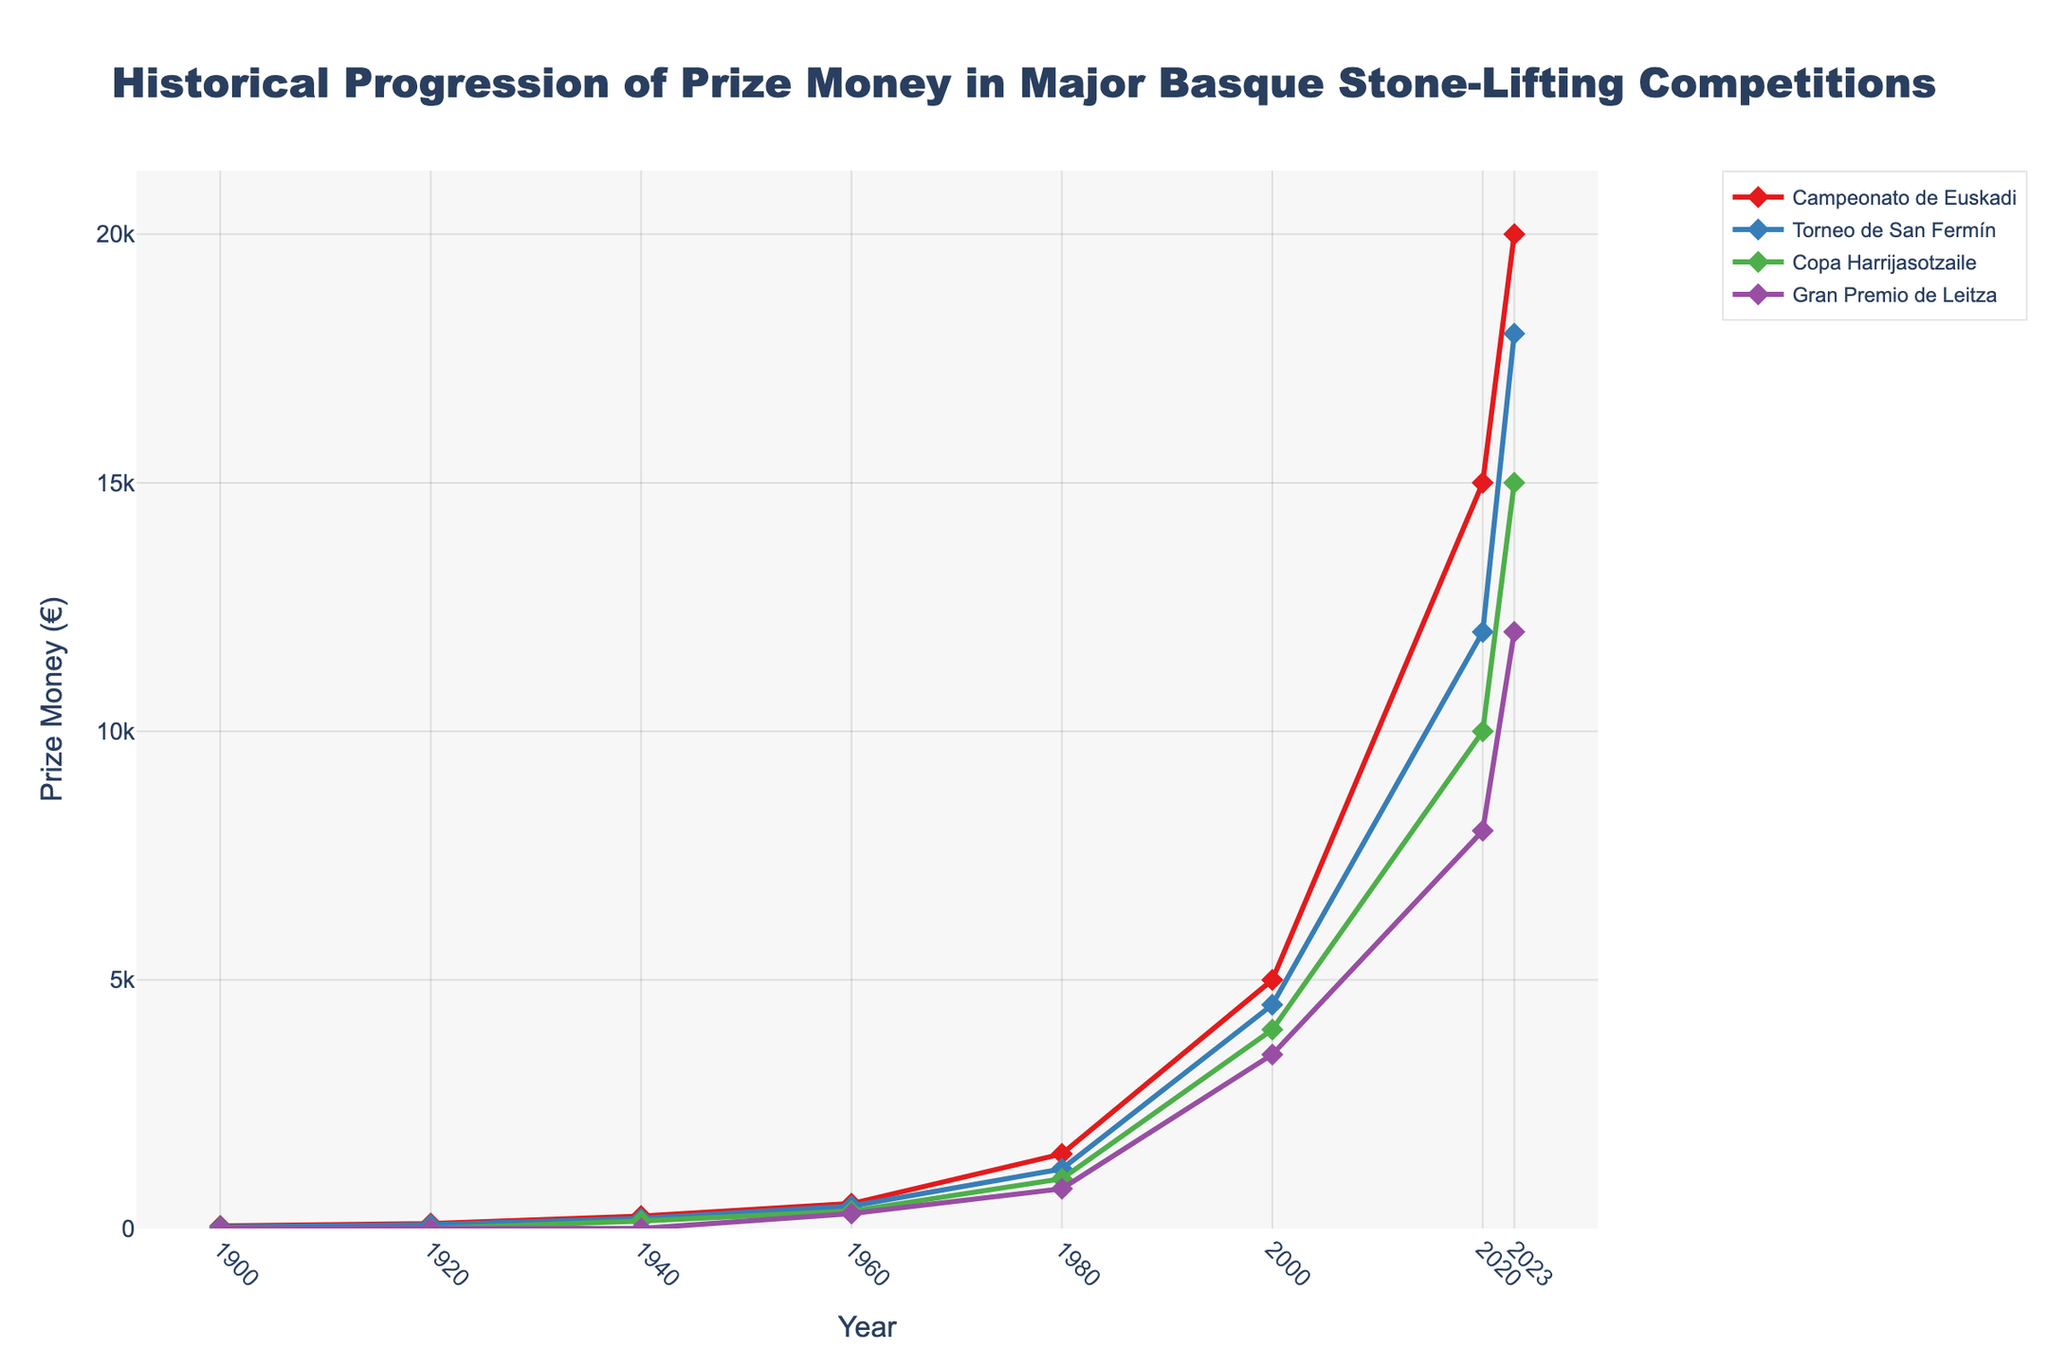What is the prize money for the "Gran Premio de Leitza" in the year 1980? First, we locate the year 1980 on the x-axis. Then, we trace upward to find the value for the "Gran Premio de Leitza" which is represented by the last colored line (possibly purple). The corresponding value is 800.
Answer: 800 Which competition had the highest prize money in 2023? We identify the year 2023 on the x-axis and then trace upward to compare the end points of all four lines. The "Campeonato de Euskadi," represented by the red-colored line, reaches the highest point of 20000.
Answer: Campeonato de Euskadi How much did the prize money for the "Torneo de San Fermín" increase from 2000 to 2020? Locate the years 2000 and 2020 on the x-axis and trace the corresponding values for "Torneo de San Fermín" (possibly blue-colored line). The values are 4500 in 2000 and 12000 in 2020. The increase is calculated as 12000 - 4500 = 7500.
Answer: 7500 Which competition had the largest increase in prize money between 1900 and 1980? First, observe the prize money values for 1900 and 1980 for each competition: Campeonato de Euskadi (50 to 1500), Torneo de San Fermín (30 to 1200), Copa Harrijasotzaile (0 to 1000), Gran Premio de Leitza (0 to 800). Calculating the increases: Campeonato de Euskadi increased by 1450, Torneo de San Fermín by 1170, Copa Harrijasotzaile by 1000, and Gran Premio de Leitza by 800. The Campeonato de Euskadi had the largest increase of 1450.
Answer: Campeonato de Euskadi In which decade did the "Copa Harrijasotzaile" first appear with non-zero prize money? Observe the "Copa Harrijasotzaile" line (likely green-colored line) and find the first point where the value is greater than zero. This occurs between 1920 and 1940, indicating it first appears in the 1940s.
Answer: 1940s What is the difference in prize money for the "Gran Premio de Leitza" between 2000 and 2023? Locate the years 2000 and 2023 on the x-axis and trace the corresponding values for "Gran Premio de Leitza" (possibly purple-colored line). The values are 3500 in 2000 and 12000 in 2023. The difference is calculated as 12000 - 3500 = 8500.
Answer: 8500 Which competition had the lowest prize money in 1940? Identify the year 1940 on the x-axis and compare the prize money values for all four competitions. The values are: Campeonato de Euskadi (250), Torneo de San Fermín (200), Copa Harrijasotzaile (150), Gran Premio de Leitza (0). The "Gran Premio de Leitza" had the lowest prize money, which is 0.
Answer: Gran Premio de Leitza By how much did the prize money for the "Campeonato de Euskadi" increase between 1940 and 2023? Locate the years 1940 and 2023 on the x-axis and trace the corresponding values for "Campeonato de Euskadi" (possibly red-colored line). The values are 250 in 1940 and 20000 in 2023. The increase is calculated as 20000 - 250 = 19750.
Answer: 19750 Which competition had its prize money increase by exactly 4000 euros between any two consecutive data points? Observe the lines and values between consecutive points. The "Copa Harrijasotzaile" increased from 1000 to 5000 euros between 1980 and 2000, which is an increase of exactly 4000 euros.
Answer: Copa Harrijasotzaile 